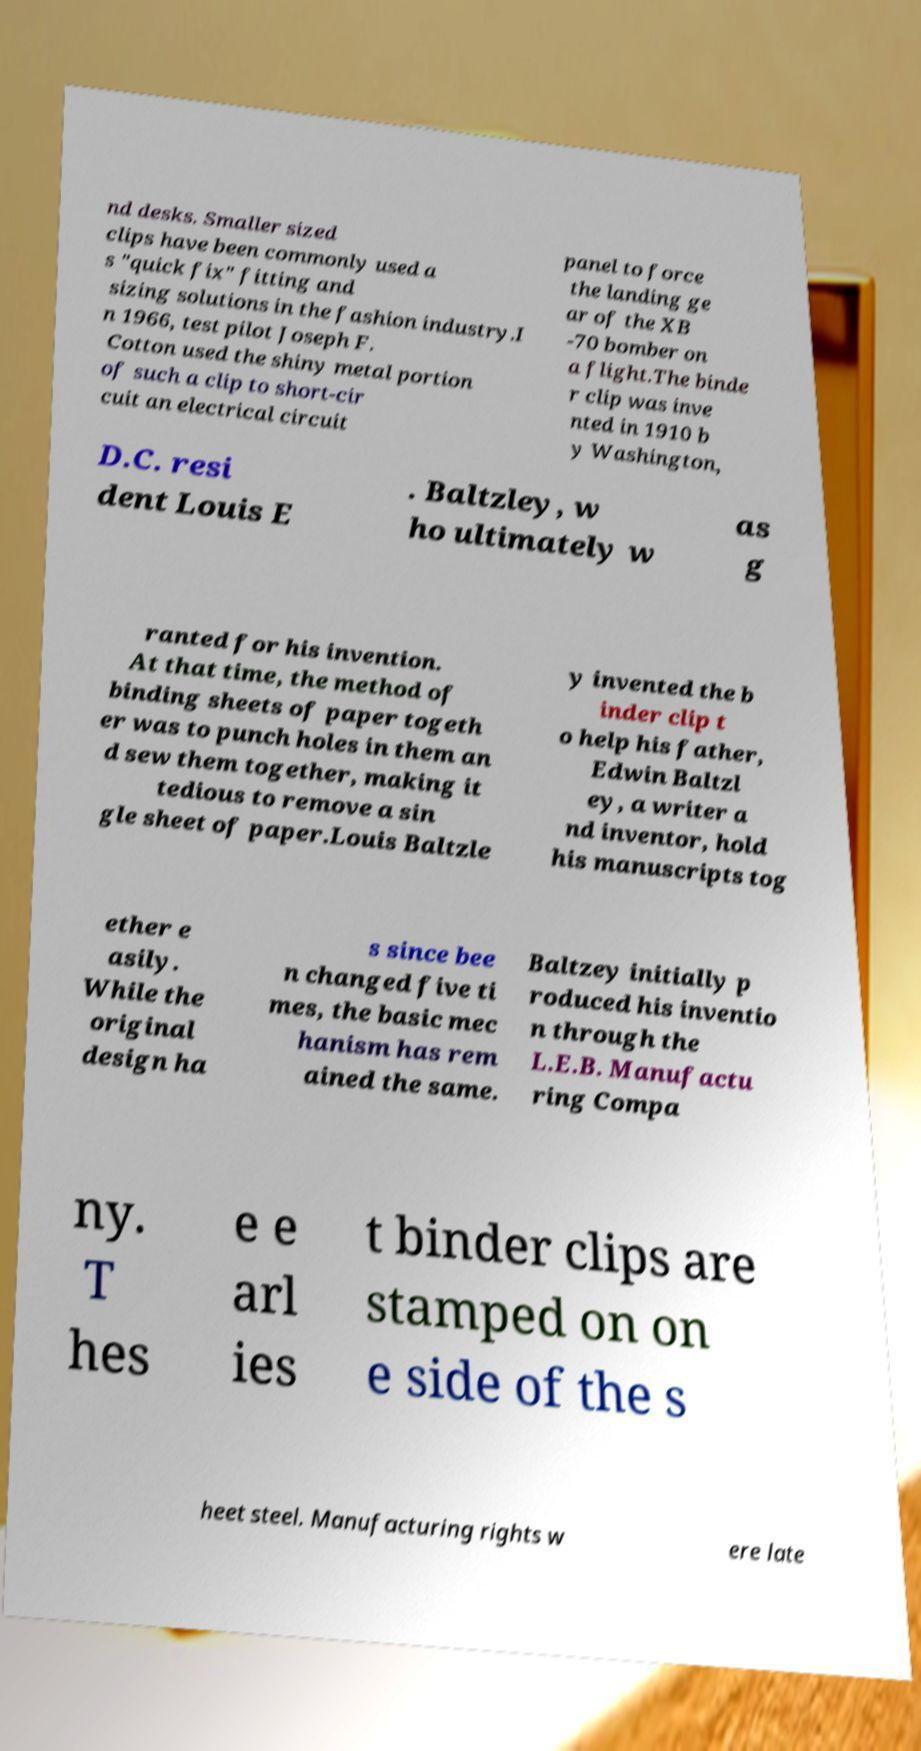For documentation purposes, I need the text within this image transcribed. Could you provide that? nd desks. Smaller sized clips have been commonly used a s "quick fix" fitting and sizing solutions in the fashion industry.I n 1966, test pilot Joseph F. Cotton used the shiny metal portion of such a clip to short-cir cuit an electrical circuit panel to force the landing ge ar of the XB -70 bomber on a flight.The binde r clip was inve nted in 1910 b y Washington, D.C. resi dent Louis E . Baltzley, w ho ultimately w as g ranted for his invention. At that time, the method of binding sheets of paper togeth er was to punch holes in them an d sew them together, making it tedious to remove a sin gle sheet of paper.Louis Baltzle y invented the b inder clip t o help his father, Edwin Baltzl ey, a writer a nd inventor, hold his manuscripts tog ether e asily. While the original design ha s since bee n changed five ti mes, the basic mec hanism has rem ained the same. Baltzey initially p roduced his inventio n through the L.E.B. Manufactu ring Compa ny. T hes e e arl ies t binder clips are stamped on on e side of the s heet steel. Manufacturing rights w ere late 